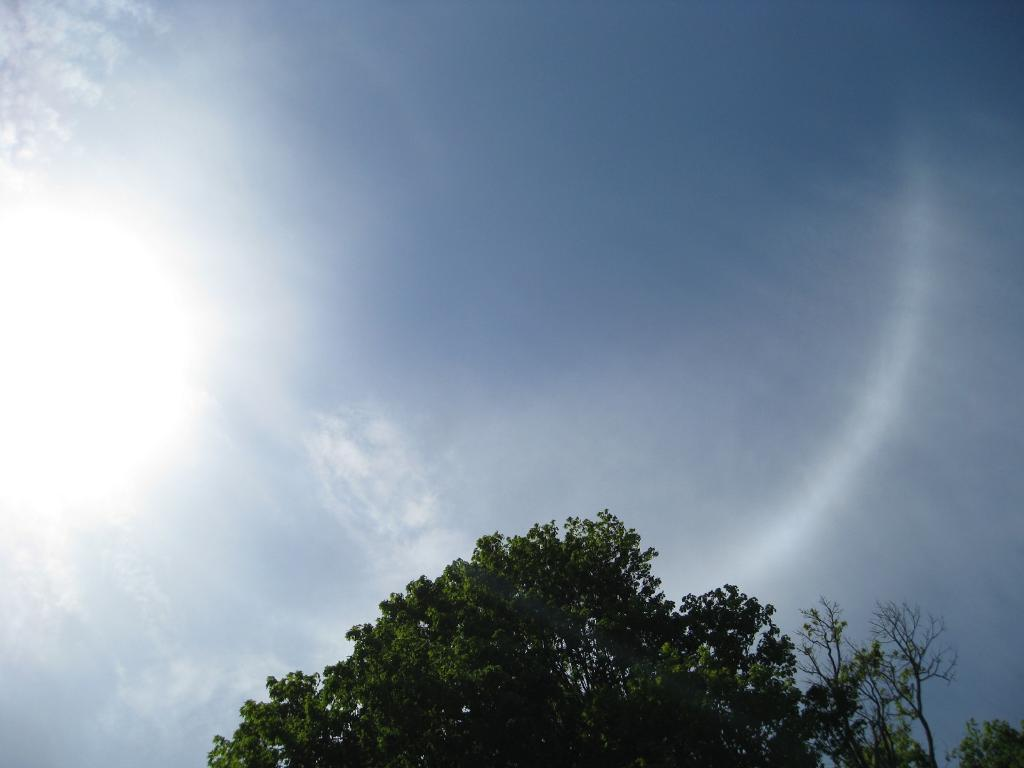What type of plant can be seen in the image? There is a tree in the image. What color is the sky in the image? The sky is blue in the image. Can you see the ant climbing the tree in the image? There is no ant present in the image. What type of doll is sitting under the tree in the image? There is no doll present in the image. 